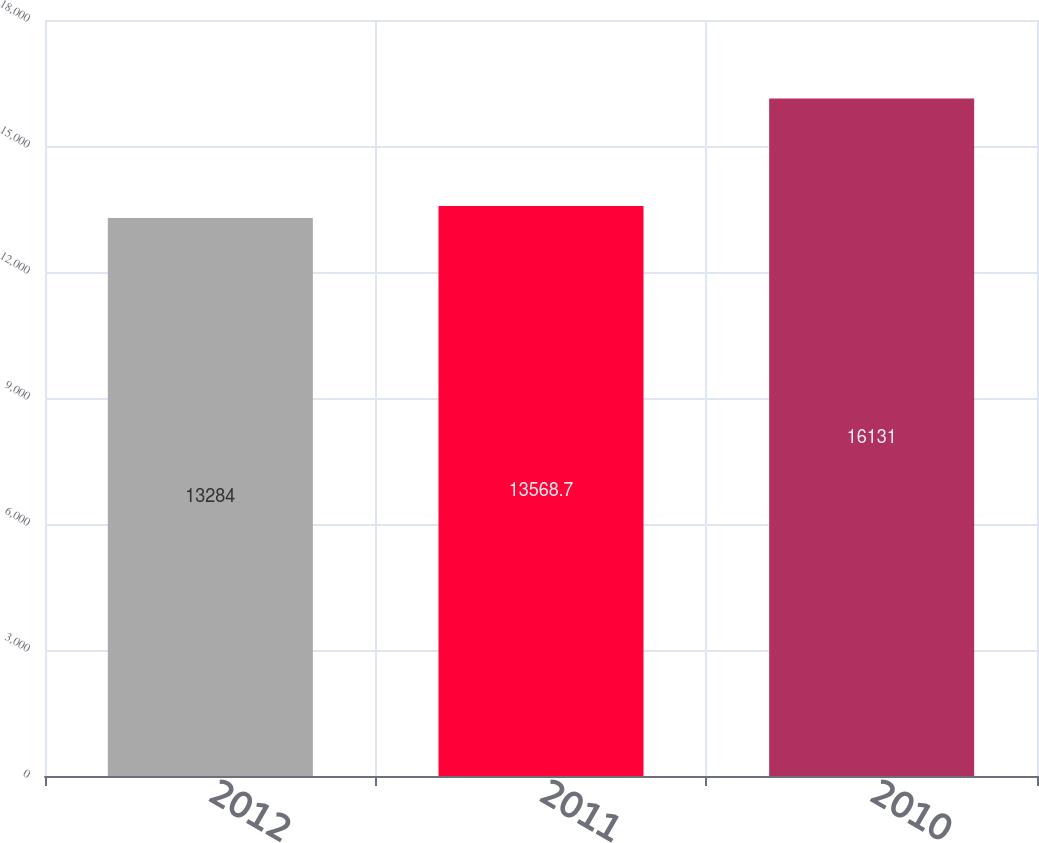Convert chart. <chart><loc_0><loc_0><loc_500><loc_500><bar_chart><fcel>2012<fcel>2011<fcel>2010<nl><fcel>13284<fcel>13568.7<fcel>16131<nl></chart> 